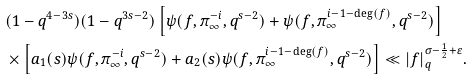<formula> <loc_0><loc_0><loc_500><loc_500>& ( 1 - q ^ { 4 - 3 s } ) ( 1 - q ^ { 3 s - 2 } ) \left [ \psi ( f , \pi _ { \infty } ^ { - i } , q ^ { s - 2 } ) + \psi ( f , \pi _ { \infty } ^ { i - 1 - \deg ( f ) } , q ^ { s - 2 } ) \right ] \\ & \times \left [ a _ { 1 } ( s ) \psi ( f , \pi _ { \infty } ^ { - i } , q ^ { s - 2 } ) + a _ { 2 } ( s ) \psi ( f , \pi _ { \infty } ^ { i - 1 - \deg ( f ) } , q ^ { s - 2 } ) \right ] \ll | f | _ { q } ^ { \sigma - \frac { 1 } { 2 } + \varepsilon } .</formula> 